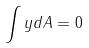Convert formula to latex. <formula><loc_0><loc_0><loc_500><loc_500>\int y d A = 0</formula> 